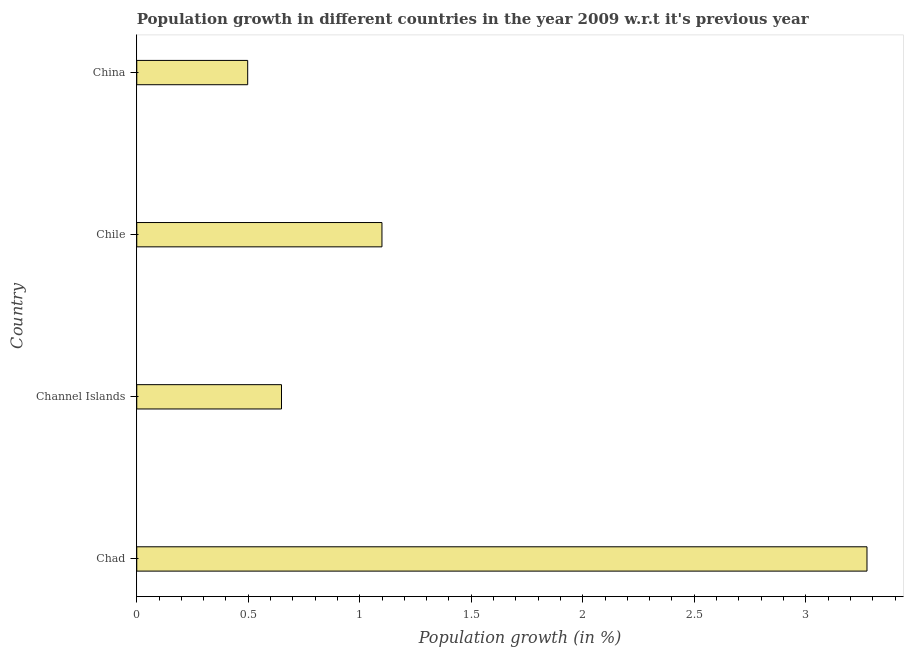Does the graph contain grids?
Give a very brief answer. No. What is the title of the graph?
Your answer should be compact. Population growth in different countries in the year 2009 w.r.t it's previous year. What is the label or title of the X-axis?
Provide a short and direct response. Population growth (in %). What is the label or title of the Y-axis?
Offer a very short reply. Country. What is the population growth in China?
Offer a terse response. 0.5. Across all countries, what is the maximum population growth?
Provide a short and direct response. 3.27. Across all countries, what is the minimum population growth?
Your response must be concise. 0.5. In which country was the population growth maximum?
Give a very brief answer. Chad. What is the sum of the population growth?
Your response must be concise. 5.52. What is the difference between the population growth in Chile and China?
Keep it short and to the point. 0.6. What is the average population growth per country?
Offer a very short reply. 1.38. What is the median population growth?
Your response must be concise. 0.87. What is the ratio of the population growth in Channel Islands to that in Chile?
Give a very brief answer. 0.59. Is the population growth in Chad less than that in China?
Provide a short and direct response. No. What is the difference between the highest and the second highest population growth?
Make the answer very short. 2.17. What is the difference between the highest and the lowest population growth?
Give a very brief answer. 2.78. In how many countries, is the population growth greater than the average population growth taken over all countries?
Keep it short and to the point. 1. How many countries are there in the graph?
Provide a short and direct response. 4. What is the difference between two consecutive major ticks on the X-axis?
Ensure brevity in your answer.  0.5. What is the Population growth (in %) in Chad?
Ensure brevity in your answer.  3.27. What is the Population growth (in %) of Channel Islands?
Offer a terse response. 0.65. What is the Population growth (in %) in Chile?
Give a very brief answer. 1.1. What is the Population growth (in %) in China?
Offer a terse response. 0.5. What is the difference between the Population growth (in %) in Chad and Channel Islands?
Offer a terse response. 2.63. What is the difference between the Population growth (in %) in Chad and Chile?
Your answer should be very brief. 2.17. What is the difference between the Population growth (in %) in Chad and China?
Give a very brief answer. 2.78. What is the difference between the Population growth (in %) in Channel Islands and Chile?
Your response must be concise. -0.45. What is the difference between the Population growth (in %) in Channel Islands and China?
Your answer should be compact. 0.15. What is the difference between the Population growth (in %) in Chile and China?
Provide a succinct answer. 0.6. What is the ratio of the Population growth (in %) in Chad to that in Channel Islands?
Offer a terse response. 5.05. What is the ratio of the Population growth (in %) in Chad to that in Chile?
Keep it short and to the point. 2.98. What is the ratio of the Population growth (in %) in Chad to that in China?
Give a very brief answer. 6.58. What is the ratio of the Population growth (in %) in Channel Islands to that in Chile?
Provide a succinct answer. 0.59. What is the ratio of the Population growth (in %) in Channel Islands to that in China?
Offer a terse response. 1.3. What is the ratio of the Population growth (in %) in Chile to that in China?
Your answer should be compact. 2.21. 